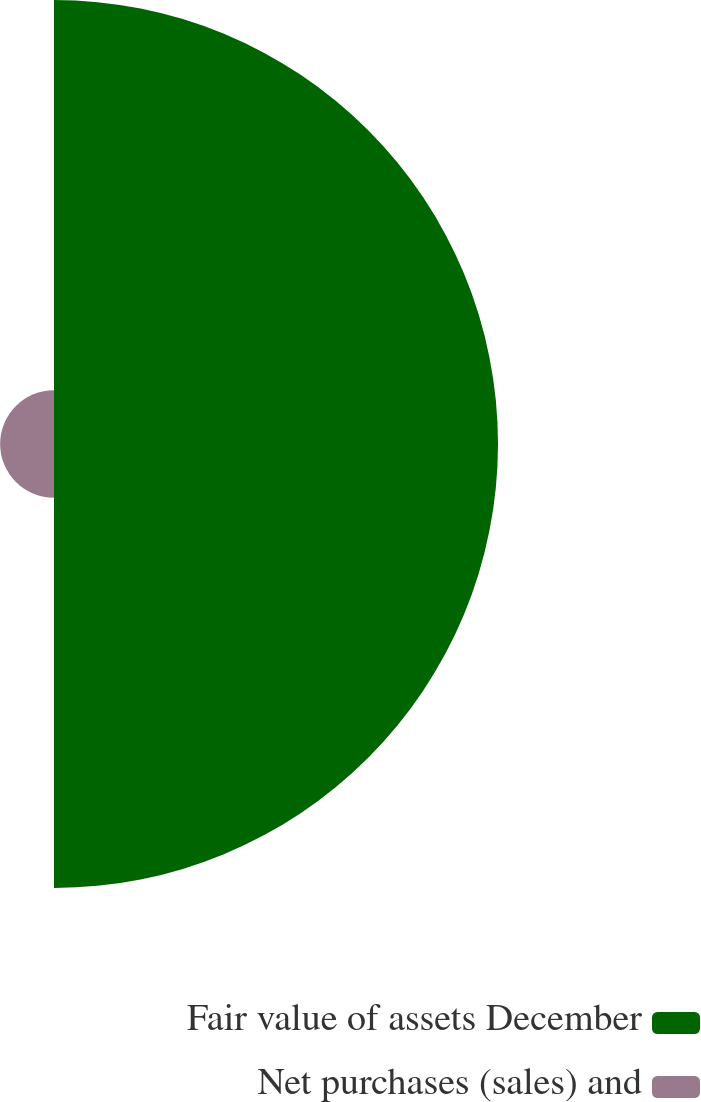Convert chart. <chart><loc_0><loc_0><loc_500><loc_500><pie_chart><fcel>Fair value of assets December<fcel>Net purchases (sales) and<nl><fcel>89.18%<fcel>10.82%<nl></chart> 